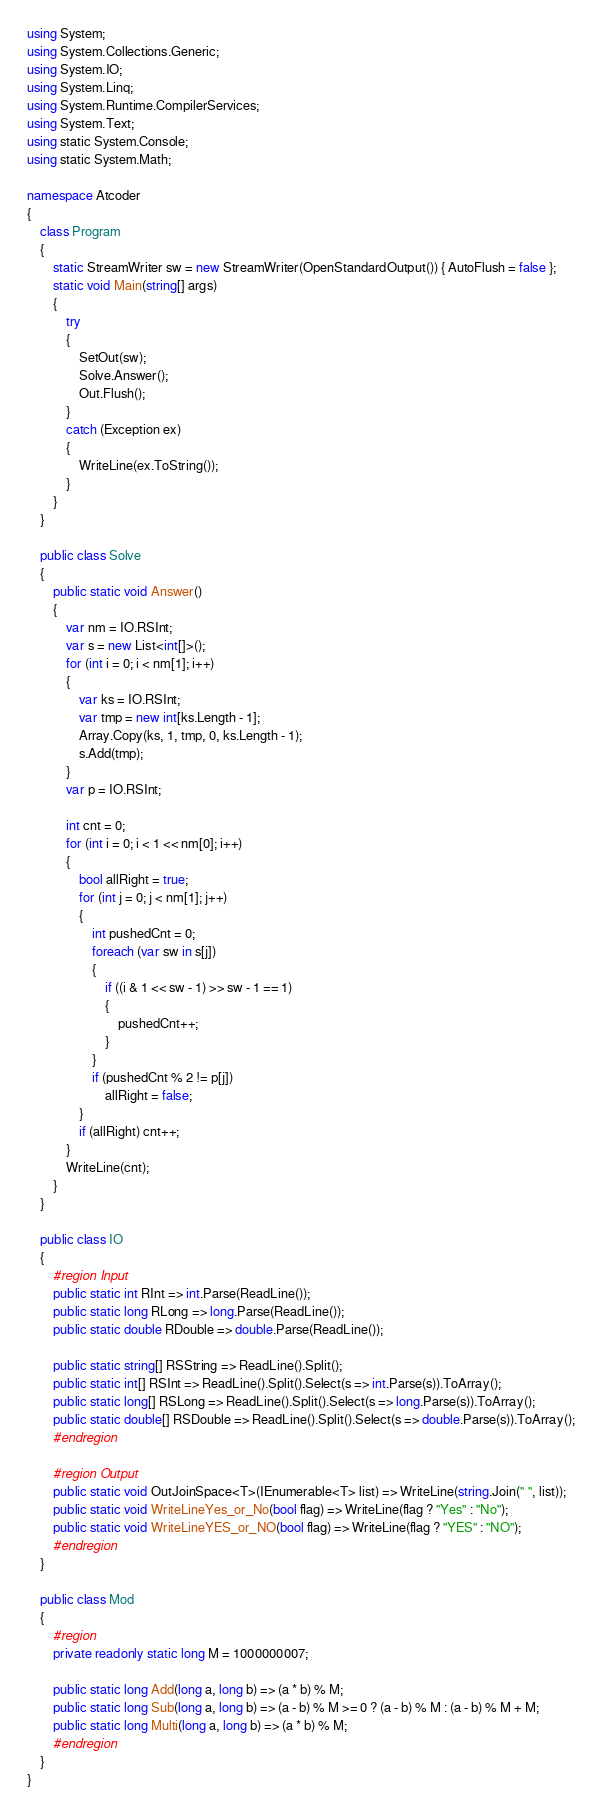<code> <loc_0><loc_0><loc_500><loc_500><_C#_>using System;
using System.Collections.Generic;
using System.IO;
using System.Linq;
using System.Runtime.CompilerServices;
using System.Text;
using static System.Console;
using static System.Math;

namespace Atcoder
{
    class Program
    {
        static StreamWriter sw = new StreamWriter(OpenStandardOutput()) { AutoFlush = false };
        static void Main(string[] args)
        {
            try
            {
                SetOut(sw);
                Solve.Answer();
                Out.Flush();
            }
            catch (Exception ex)
            {
                WriteLine(ex.ToString());
            }
        }
    }

    public class Solve
    {
        public static void Answer()
        {
            var nm = IO.RSInt;
            var s = new List<int[]>();
            for (int i = 0; i < nm[1]; i++)
            {
                var ks = IO.RSInt;
                var tmp = new int[ks.Length - 1];
                Array.Copy(ks, 1, tmp, 0, ks.Length - 1);
                s.Add(tmp);
            }
            var p = IO.RSInt;

            int cnt = 0;
            for (int i = 0; i < 1 << nm[0]; i++)
            {
                bool allRight = true;
                for (int j = 0; j < nm[1]; j++)
                {
                    int pushedCnt = 0;
                    foreach (var sw in s[j])
                    {
                        if ((i & 1 << sw - 1) >> sw - 1 == 1)
                        {
                            pushedCnt++;
                        }
                    }
                    if (pushedCnt % 2 != p[j])
                        allRight = false;
                }
                if (allRight) cnt++;
            }
            WriteLine(cnt);
        }
    }

    public class IO
    {
        #region Input
        public static int RInt => int.Parse(ReadLine());
        public static long RLong => long.Parse(ReadLine());
        public static double RDouble => double.Parse(ReadLine());

        public static string[] RSString => ReadLine().Split();
        public static int[] RSInt => ReadLine().Split().Select(s => int.Parse(s)).ToArray();
        public static long[] RSLong => ReadLine().Split().Select(s => long.Parse(s)).ToArray();
        public static double[] RSDouble => ReadLine().Split().Select(s => double.Parse(s)).ToArray();
        #endregion

        #region Output
        public static void OutJoinSpace<T>(IEnumerable<T> list) => WriteLine(string.Join(" ", list));
        public static void WriteLineYes_or_No(bool flag) => WriteLine(flag ? "Yes" : "No");
        public static void WriteLineYES_or_NO(bool flag) => WriteLine(flag ? "YES" : "NO");
        #endregion
    }

    public class Mod
    {
        #region
        private readonly static long M = 1000000007;

        public static long Add(long a, long b) => (a * b) % M;
        public static long Sub(long a, long b) => (a - b) % M >= 0 ? (a - b) % M : (a - b) % M + M;
        public static long Multi(long a, long b) => (a * b) % M;
        #endregion
    }
}</code> 